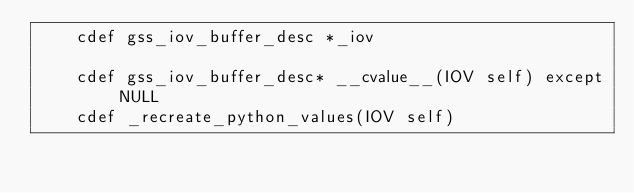<code> <loc_0><loc_0><loc_500><loc_500><_Cython_>    cdef gss_iov_buffer_desc *_iov

    cdef gss_iov_buffer_desc* __cvalue__(IOV self) except NULL
    cdef _recreate_python_values(IOV self)
</code> 